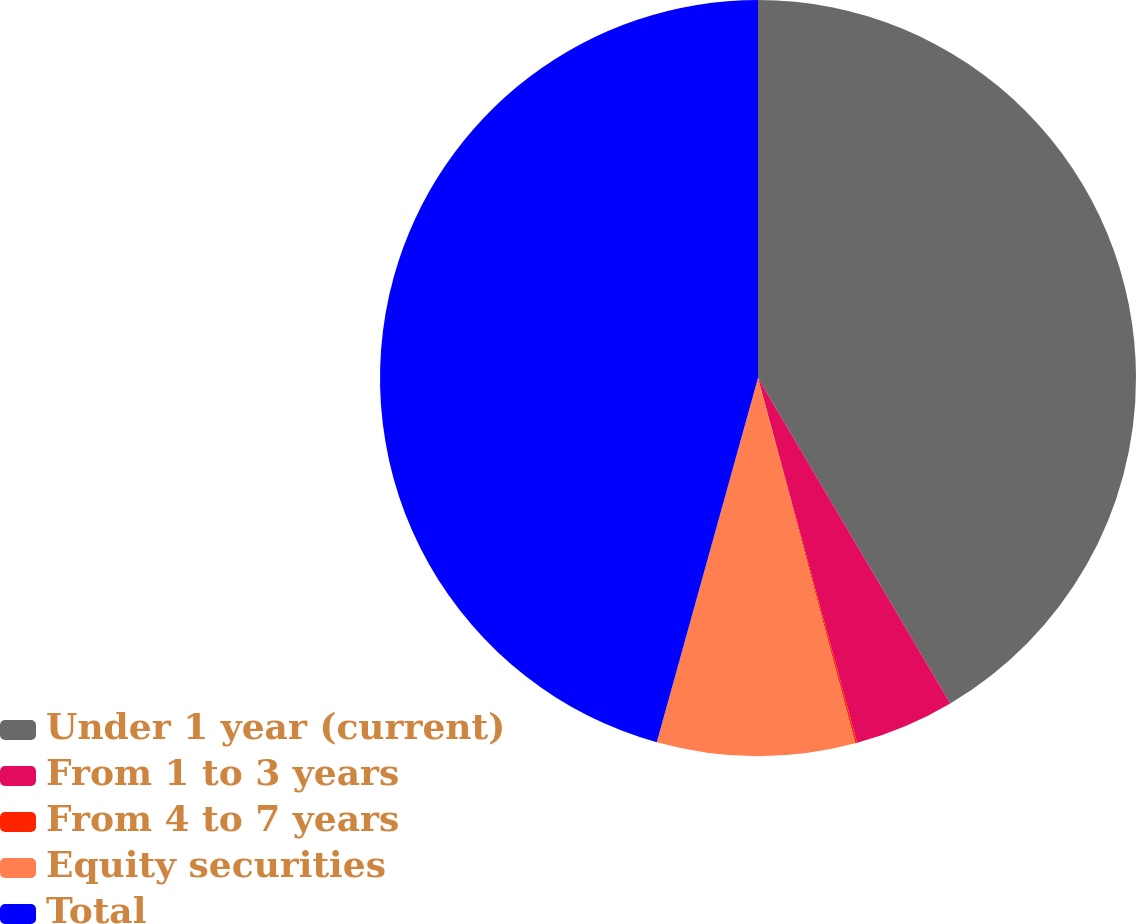<chart> <loc_0><loc_0><loc_500><loc_500><pie_chart><fcel>Under 1 year (current)<fcel>From 1 to 3 years<fcel>From 4 to 7 years<fcel>Equity securities<fcel>Total<nl><fcel>41.51%<fcel>4.27%<fcel>0.08%<fcel>8.46%<fcel>45.69%<nl></chart> 